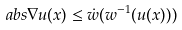<formula> <loc_0><loc_0><loc_500><loc_500>\ a b s { \nabla u ( x ) } \leq \dot { w } ( w ^ { - 1 } ( u ( x ) ) )</formula> 